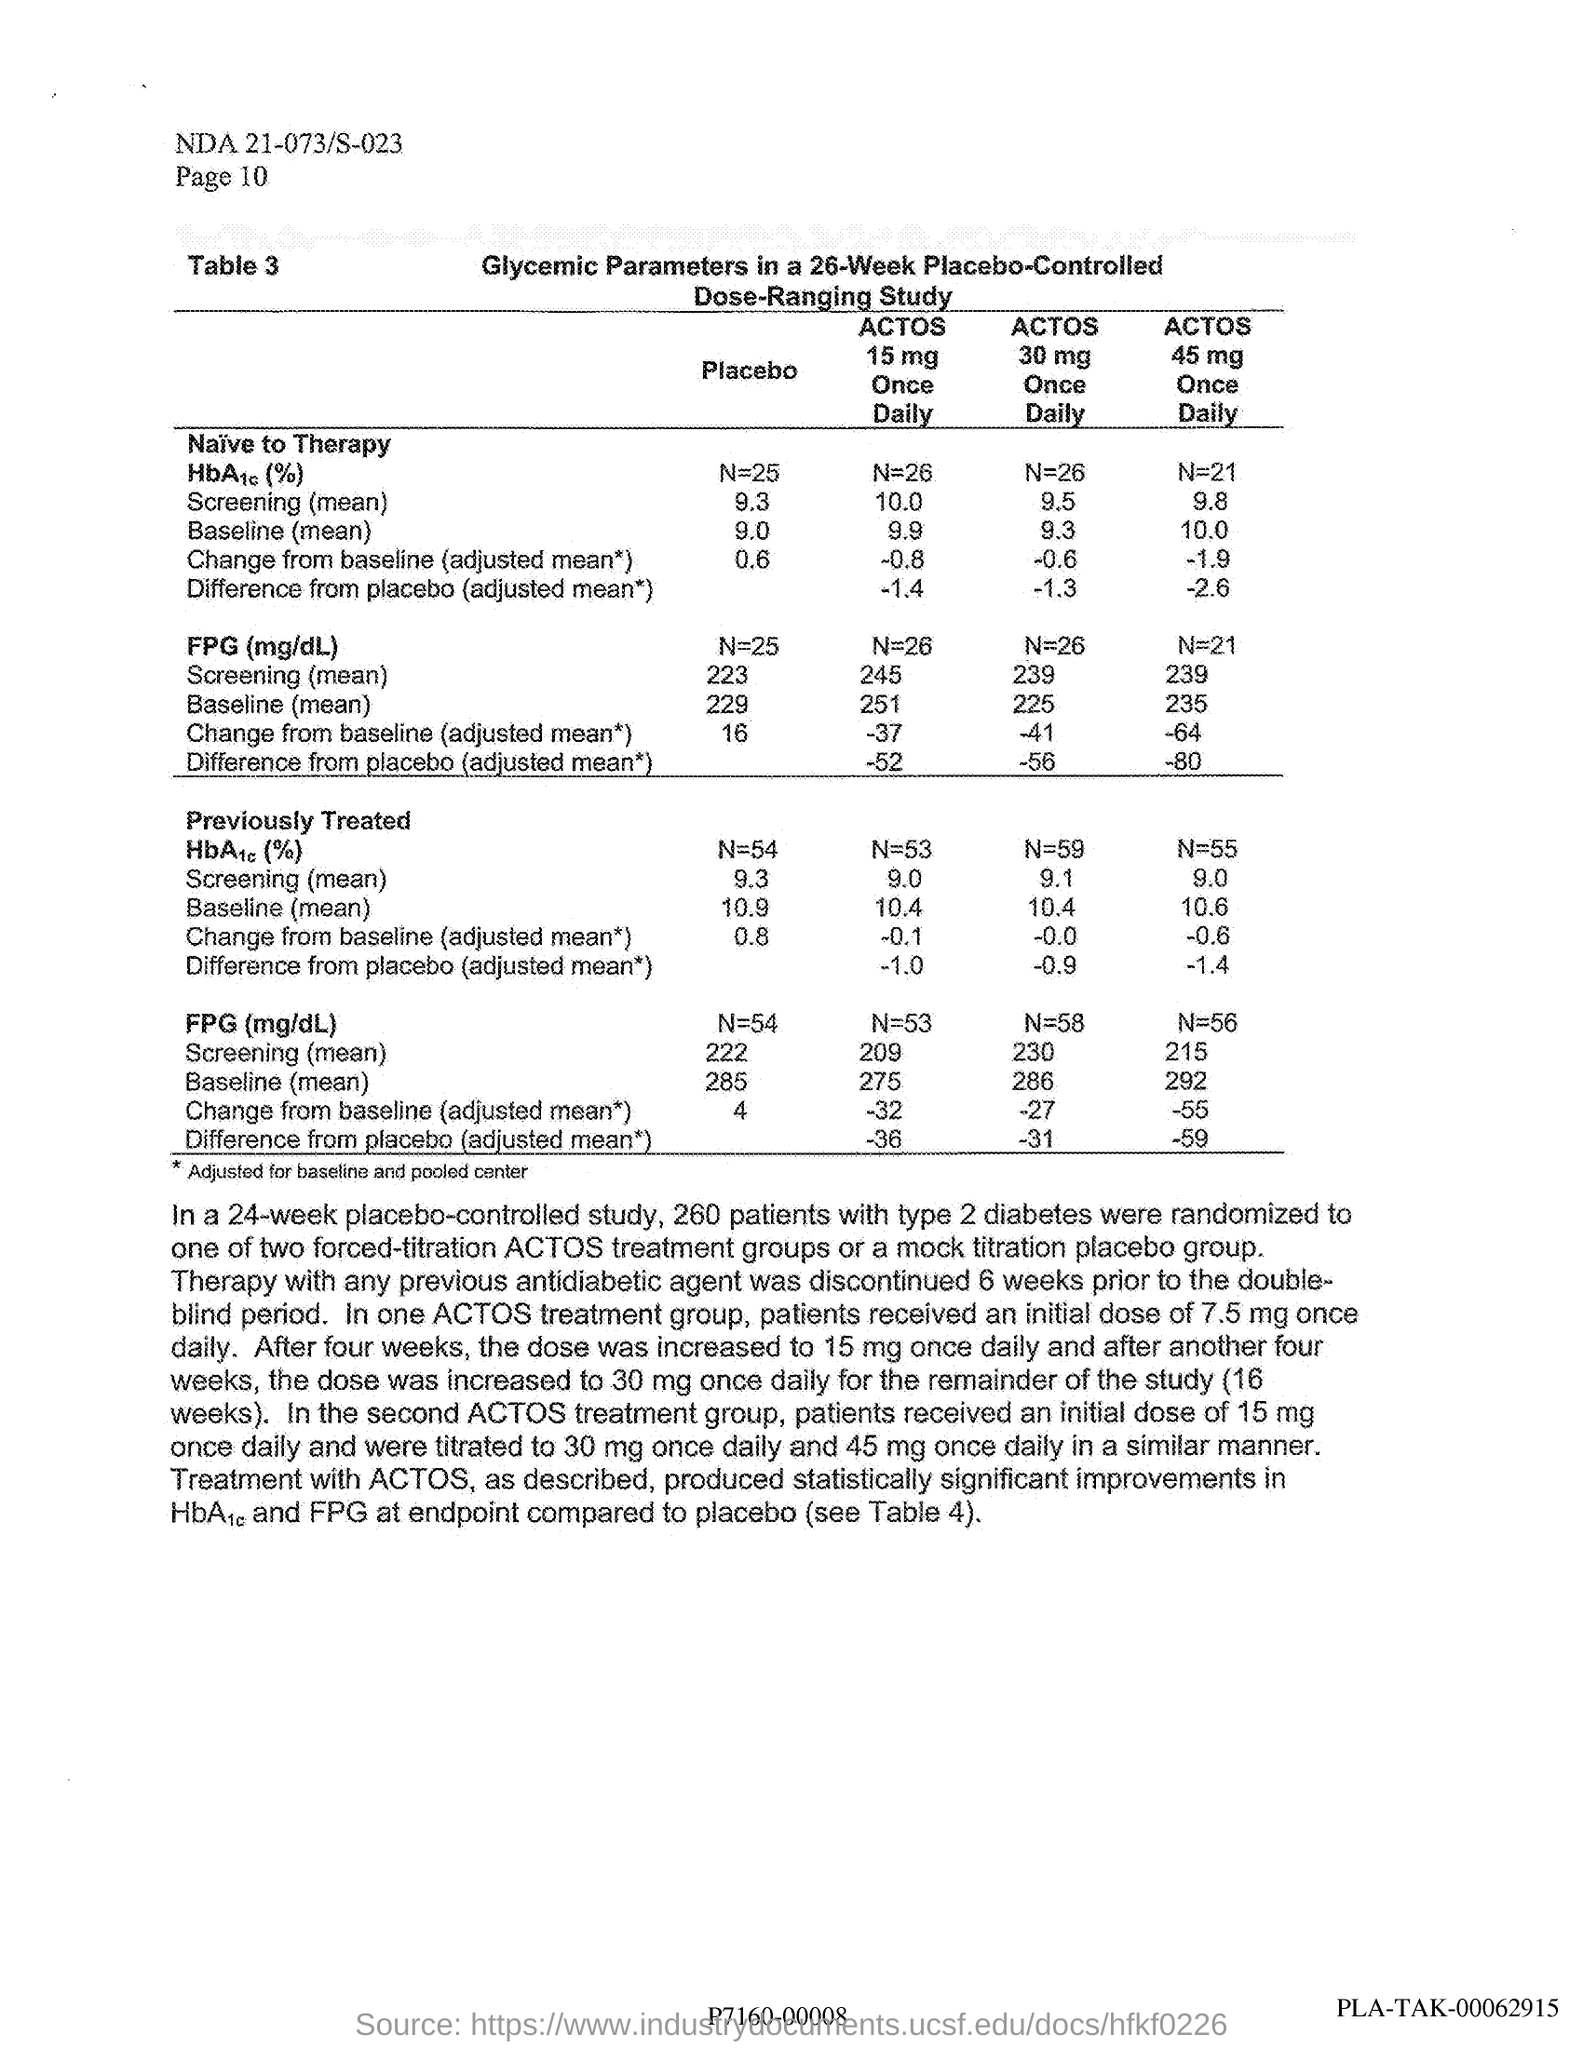In one actos treatment group how much amount of initial dose is given to the patients daily ?
Keep it short and to the point. 7.5 mg. In a 24 week placebo controlled study how many patients with type 2 diabetes were randomized ?
Your response must be concise. 260. In the second actos treatment group,how much amount of initial dose patients should receive daily ?
Keep it short and to the point. 15 mg. 